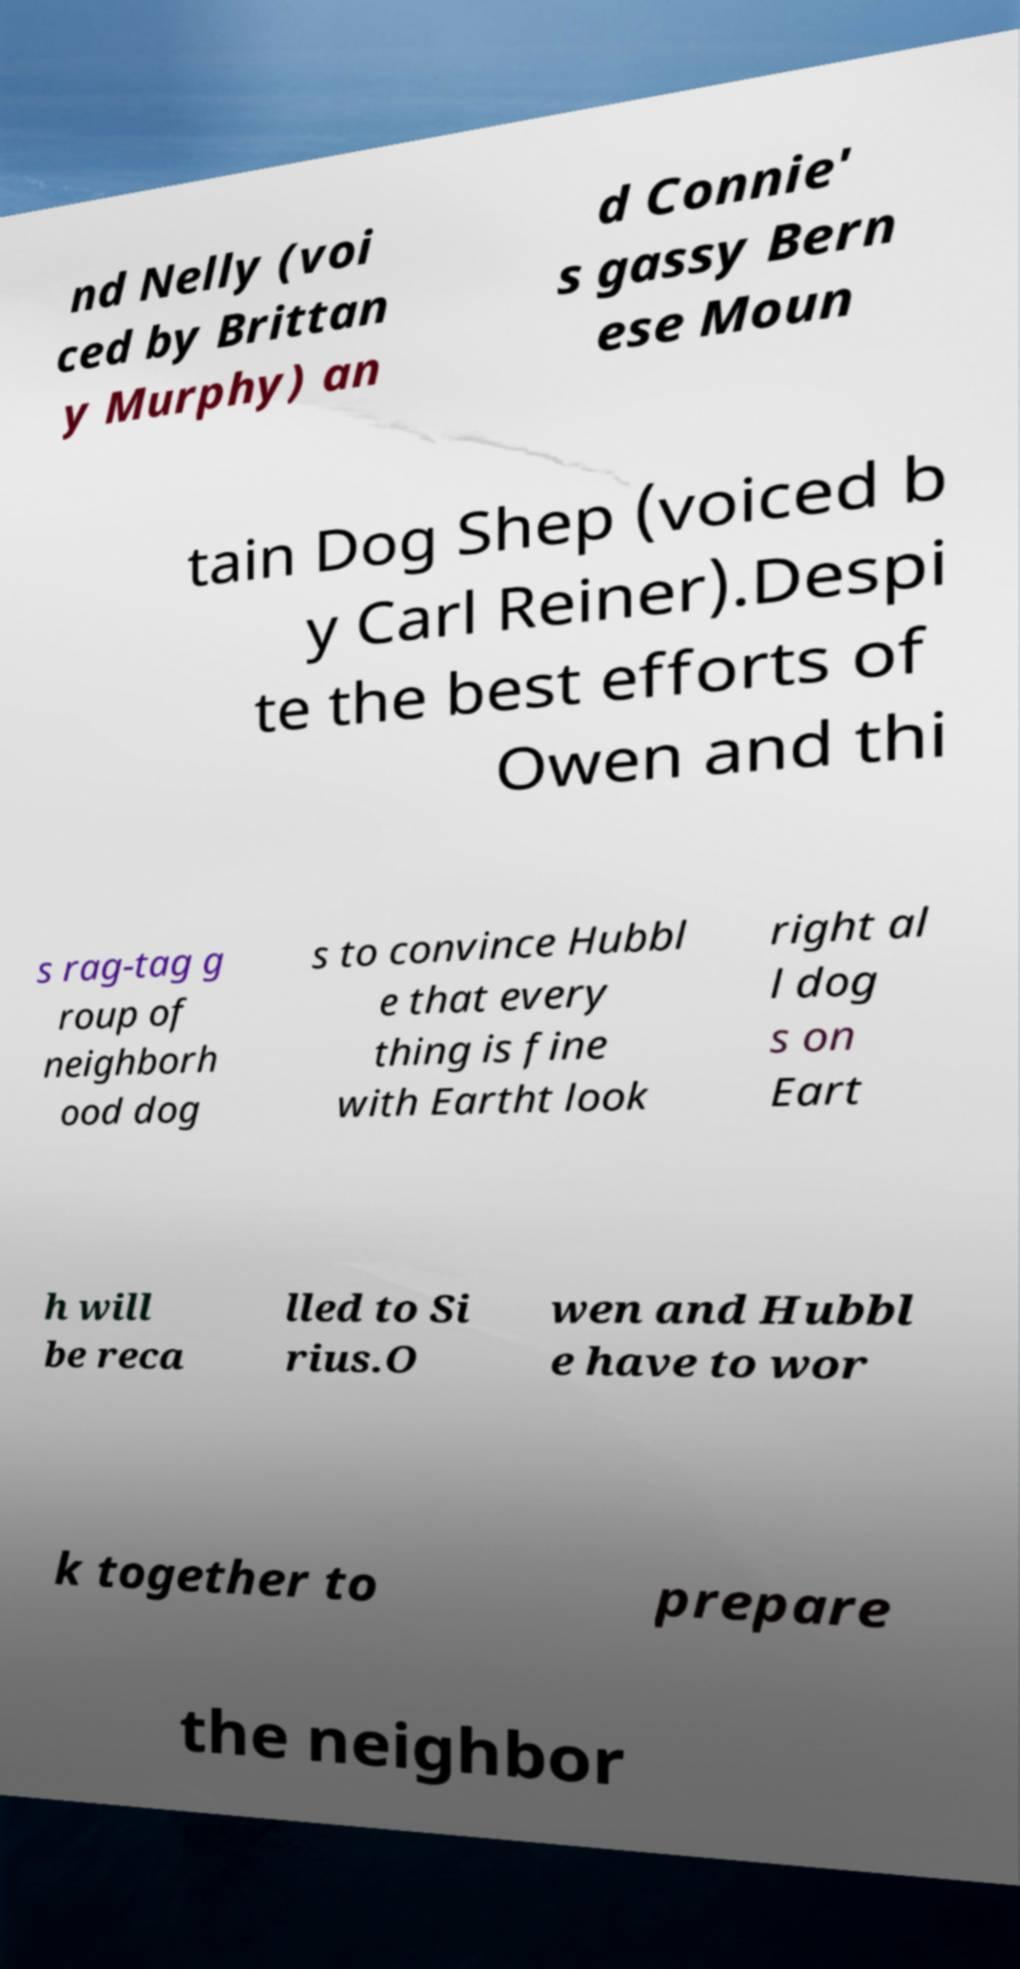Could you extract and type out the text from this image? nd Nelly (voi ced by Brittan y Murphy) an d Connie' s gassy Bern ese Moun tain Dog Shep (voiced b y Carl Reiner).Despi te the best efforts of Owen and thi s rag-tag g roup of neighborh ood dog s to convince Hubbl e that every thing is fine with Eartht look right al l dog s on Eart h will be reca lled to Si rius.O wen and Hubbl e have to wor k together to prepare the neighbor 